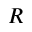Convert formula to latex. <formula><loc_0><loc_0><loc_500><loc_500>R</formula> 